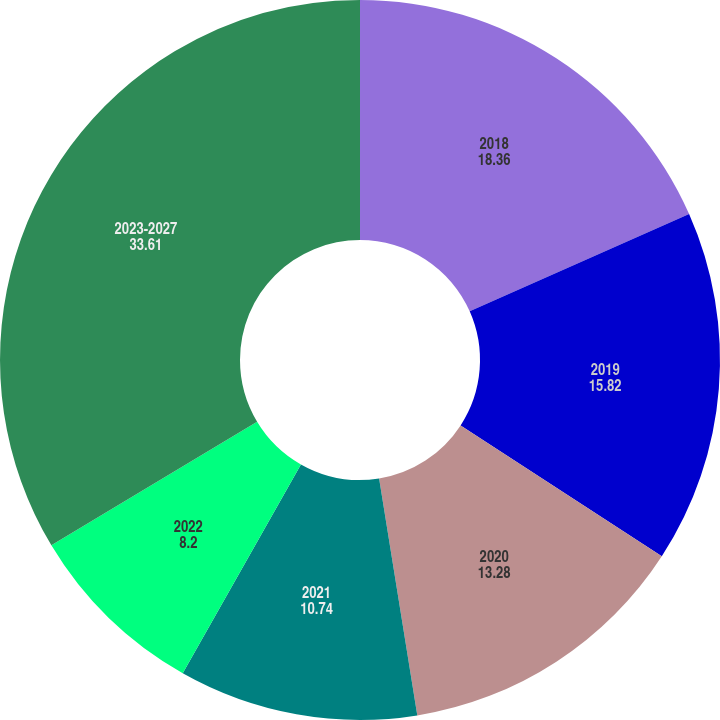Convert chart to OTSL. <chart><loc_0><loc_0><loc_500><loc_500><pie_chart><fcel>2018<fcel>2019<fcel>2020<fcel>2021<fcel>2022<fcel>2023-2027<nl><fcel>18.36%<fcel>15.82%<fcel>13.28%<fcel>10.74%<fcel>8.2%<fcel>33.61%<nl></chart> 